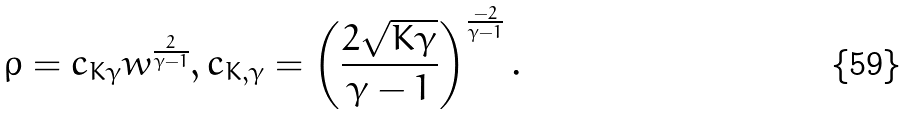<formula> <loc_0><loc_0><loc_500><loc_500>\rho = c _ { K \gamma } w ^ { \frac { 2 } { \gamma - 1 } } , c _ { K , \gamma } = \left ( \frac { 2 \sqrt { K \gamma } } { \gamma - 1 } \right ) ^ { \frac { - 2 } { \gamma - 1 } } .</formula> 